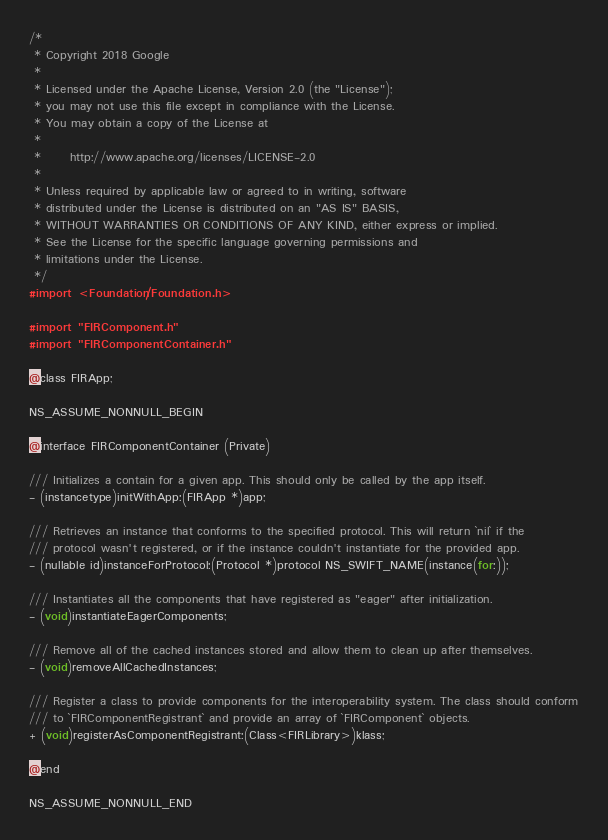<code> <loc_0><loc_0><loc_500><loc_500><_C_>/*
 * Copyright 2018 Google
 *
 * Licensed under the Apache License, Version 2.0 (the "License");
 * you may not use this file except in compliance with the License.
 * You may obtain a copy of the License at
 *
 *      http://www.apache.org/licenses/LICENSE-2.0
 *
 * Unless required by applicable law or agreed to in writing, software
 * distributed under the License is distributed on an "AS IS" BASIS,
 * WITHOUT WARRANTIES OR CONDITIONS OF ANY KIND, either express or implied.
 * See the License for the specific language governing permissions and
 * limitations under the License.
 */
#import <Foundation/Foundation.h>

#import "FIRComponent.h"
#import "FIRComponentContainer.h"

@class FIRApp;

NS_ASSUME_NONNULL_BEGIN

@interface FIRComponentContainer (Private)

/// Initializes a contain for a given app. This should only be called by the app itself.
- (instancetype)initWithApp:(FIRApp *)app;

/// Retrieves an instance that conforms to the specified protocol. This will return `nil` if the
/// protocol wasn't registered, or if the instance couldn't instantiate for the provided app.
- (nullable id)instanceForProtocol:(Protocol *)protocol NS_SWIFT_NAME(instance(for:));

/// Instantiates all the components that have registered as "eager" after initialization.
- (void)instantiateEagerComponents;

/// Remove all of the cached instances stored and allow them to clean up after themselves.
- (void)removeAllCachedInstances;

/// Register a class to provide components for the interoperability system. The class should conform
/// to `FIRComponentRegistrant` and provide an array of `FIRComponent` objects.
+ (void)registerAsComponentRegistrant:(Class<FIRLibrary>)klass;

@end

NS_ASSUME_NONNULL_END
</code> 